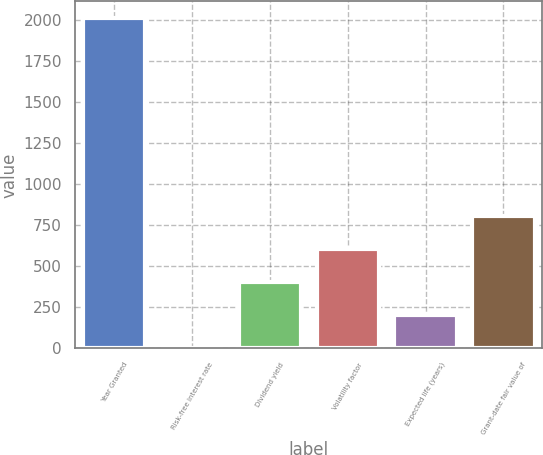<chart> <loc_0><loc_0><loc_500><loc_500><bar_chart><fcel>Year Granted<fcel>Risk-free interest rate<fcel>Dividend yield<fcel>Volatility factor<fcel>Expected life (years)<fcel>Grant-date fair value of<nl><fcel>2015<fcel>0.9<fcel>403.72<fcel>605.13<fcel>202.31<fcel>806.54<nl></chart> 